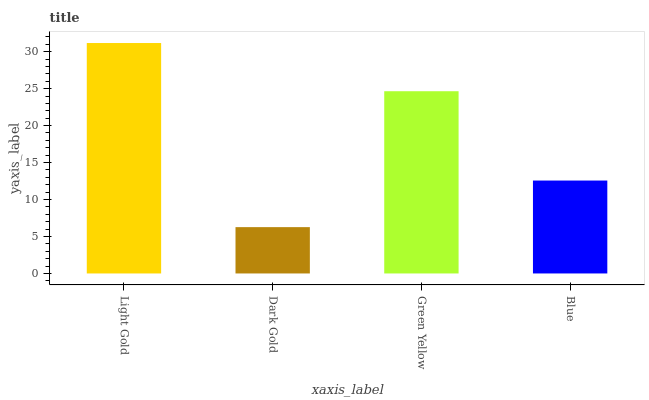Is Dark Gold the minimum?
Answer yes or no. Yes. Is Light Gold the maximum?
Answer yes or no. Yes. Is Green Yellow the minimum?
Answer yes or no. No. Is Green Yellow the maximum?
Answer yes or no. No. Is Green Yellow greater than Dark Gold?
Answer yes or no. Yes. Is Dark Gold less than Green Yellow?
Answer yes or no. Yes. Is Dark Gold greater than Green Yellow?
Answer yes or no. No. Is Green Yellow less than Dark Gold?
Answer yes or no. No. Is Green Yellow the high median?
Answer yes or no. Yes. Is Blue the low median?
Answer yes or no. Yes. Is Blue the high median?
Answer yes or no. No. Is Light Gold the low median?
Answer yes or no. No. 